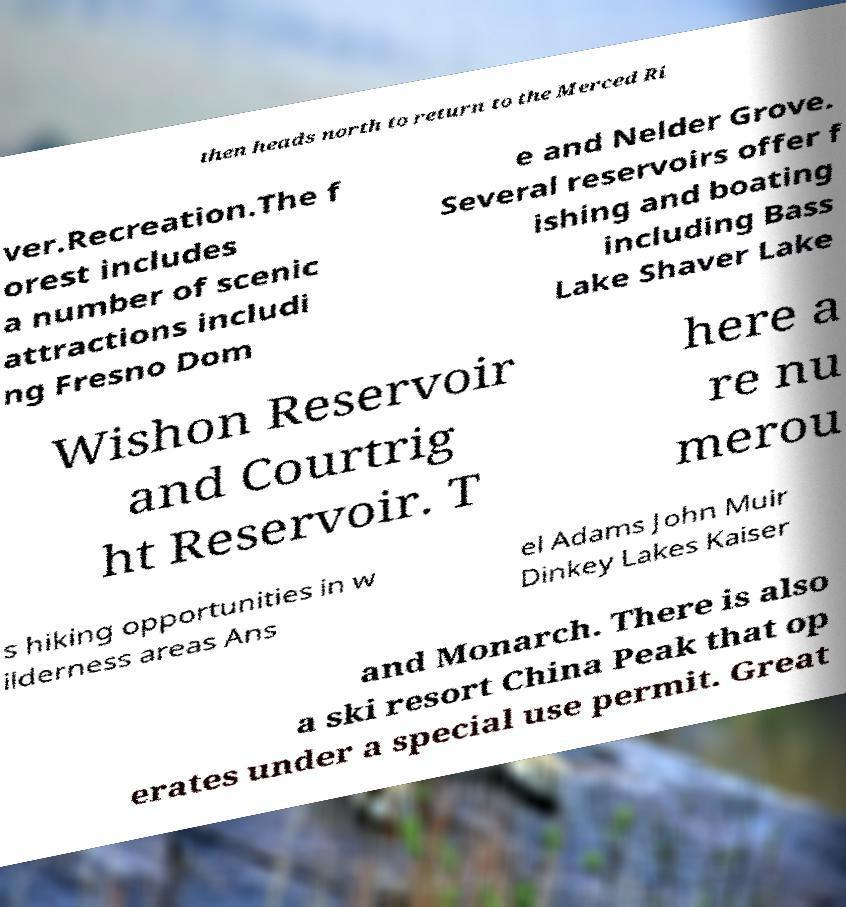What messages or text are displayed in this image? I need them in a readable, typed format. then heads north to return to the Merced Ri ver.Recreation.The f orest includes a number of scenic attractions includi ng Fresno Dom e and Nelder Grove. Several reservoirs offer f ishing and boating including Bass Lake Shaver Lake Wishon Reservoir and Courtrig ht Reservoir. T here a re nu merou s hiking opportunities in w ilderness areas Ans el Adams John Muir Dinkey Lakes Kaiser and Monarch. There is also a ski resort China Peak that op erates under a special use permit. Great 